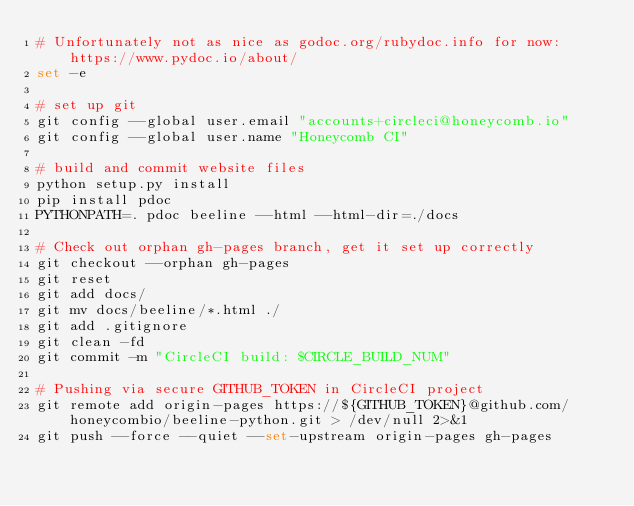<code> <loc_0><loc_0><loc_500><loc_500><_Bash_># Unfortunately not as nice as godoc.org/rubydoc.info for now: https://www.pydoc.io/about/
set -e

# set up git
git config --global user.email "accounts+circleci@honeycomb.io"
git config --global user.name "Honeycomb CI"

# build and commit website files
python setup.py install
pip install pdoc
PYTHONPATH=. pdoc beeline --html --html-dir=./docs

# Check out orphan gh-pages branch, get it set up correctly
git checkout --orphan gh-pages
git reset
git add docs/
git mv docs/beeline/*.html ./
git add .gitignore
git clean -fd
git commit -m "CircleCI build: $CIRCLE_BUILD_NUM"

# Pushing via secure GITHUB_TOKEN in CircleCI project
git remote add origin-pages https://${GITHUB_TOKEN}@github.com/honeycombio/beeline-python.git > /dev/null 2>&1
git push --force --quiet --set-upstream origin-pages gh-pages
</code> 